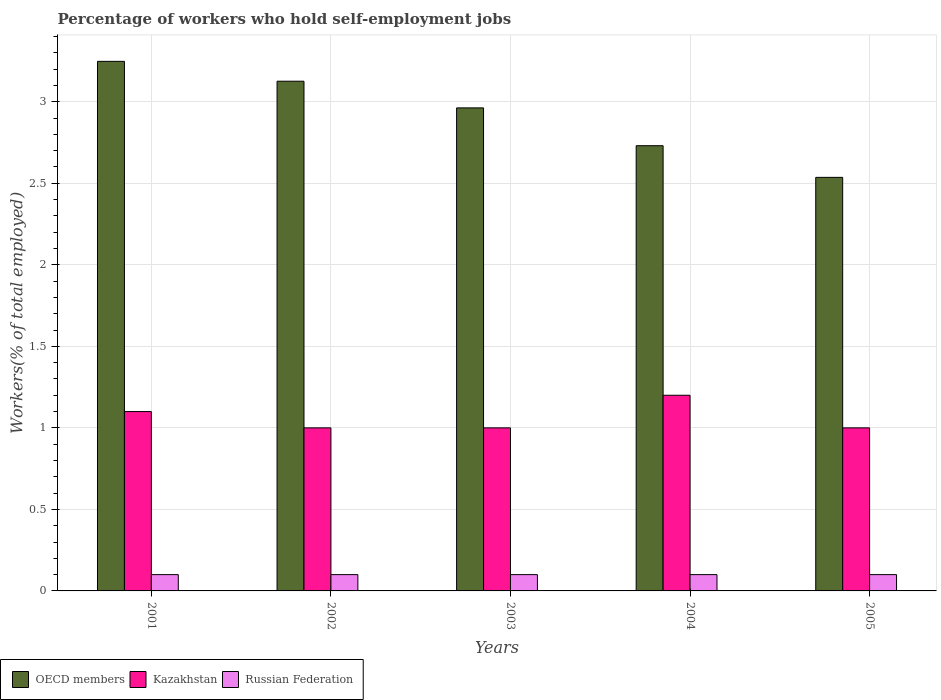How many groups of bars are there?
Your answer should be very brief. 5. What is the percentage of self-employed workers in Russian Federation in 2002?
Your response must be concise. 0.1. Across all years, what is the maximum percentage of self-employed workers in OECD members?
Your answer should be very brief. 3.25. In which year was the percentage of self-employed workers in OECD members minimum?
Your answer should be very brief. 2005. What is the total percentage of self-employed workers in OECD members in the graph?
Ensure brevity in your answer.  14.6. What is the difference between the percentage of self-employed workers in Kazakhstan in 2002 and that in 2003?
Keep it short and to the point. 0. What is the difference between the percentage of self-employed workers in Kazakhstan in 2001 and the percentage of self-employed workers in OECD members in 2002?
Offer a terse response. -2.03. What is the average percentage of self-employed workers in Kazakhstan per year?
Ensure brevity in your answer.  1.06. In the year 2001, what is the difference between the percentage of self-employed workers in Russian Federation and percentage of self-employed workers in Kazakhstan?
Provide a succinct answer. -1. Is the percentage of self-employed workers in Russian Federation in 2001 less than that in 2005?
Give a very brief answer. No. Is the difference between the percentage of self-employed workers in Russian Federation in 2002 and 2003 greater than the difference between the percentage of self-employed workers in Kazakhstan in 2002 and 2003?
Make the answer very short. No. What is the difference between the highest and the lowest percentage of self-employed workers in Russian Federation?
Give a very brief answer. 0. Is the sum of the percentage of self-employed workers in OECD members in 2001 and 2003 greater than the maximum percentage of self-employed workers in Russian Federation across all years?
Give a very brief answer. Yes. What does the 2nd bar from the left in 2003 represents?
Keep it short and to the point. Kazakhstan. How many bars are there?
Make the answer very short. 15. Are all the bars in the graph horizontal?
Make the answer very short. No. Does the graph contain any zero values?
Your response must be concise. No. Where does the legend appear in the graph?
Keep it short and to the point. Bottom left. What is the title of the graph?
Provide a short and direct response. Percentage of workers who hold self-employment jobs. Does "Slovak Republic" appear as one of the legend labels in the graph?
Provide a short and direct response. No. What is the label or title of the X-axis?
Your answer should be compact. Years. What is the label or title of the Y-axis?
Give a very brief answer. Workers(% of total employed). What is the Workers(% of total employed) of OECD members in 2001?
Provide a succinct answer. 3.25. What is the Workers(% of total employed) of Kazakhstan in 2001?
Give a very brief answer. 1.1. What is the Workers(% of total employed) in Russian Federation in 2001?
Provide a succinct answer. 0.1. What is the Workers(% of total employed) in OECD members in 2002?
Give a very brief answer. 3.13. What is the Workers(% of total employed) of Kazakhstan in 2002?
Keep it short and to the point. 1. What is the Workers(% of total employed) in Russian Federation in 2002?
Offer a very short reply. 0.1. What is the Workers(% of total employed) of OECD members in 2003?
Ensure brevity in your answer.  2.96. What is the Workers(% of total employed) in Kazakhstan in 2003?
Provide a succinct answer. 1. What is the Workers(% of total employed) in Russian Federation in 2003?
Offer a terse response. 0.1. What is the Workers(% of total employed) in OECD members in 2004?
Keep it short and to the point. 2.73. What is the Workers(% of total employed) in Kazakhstan in 2004?
Give a very brief answer. 1.2. What is the Workers(% of total employed) of Russian Federation in 2004?
Provide a succinct answer. 0.1. What is the Workers(% of total employed) in OECD members in 2005?
Ensure brevity in your answer.  2.54. What is the Workers(% of total employed) in Kazakhstan in 2005?
Your response must be concise. 1. What is the Workers(% of total employed) of Russian Federation in 2005?
Provide a succinct answer. 0.1. Across all years, what is the maximum Workers(% of total employed) of OECD members?
Ensure brevity in your answer.  3.25. Across all years, what is the maximum Workers(% of total employed) in Kazakhstan?
Offer a terse response. 1.2. Across all years, what is the maximum Workers(% of total employed) in Russian Federation?
Keep it short and to the point. 0.1. Across all years, what is the minimum Workers(% of total employed) of OECD members?
Your response must be concise. 2.54. Across all years, what is the minimum Workers(% of total employed) of Kazakhstan?
Keep it short and to the point. 1. Across all years, what is the minimum Workers(% of total employed) of Russian Federation?
Ensure brevity in your answer.  0.1. What is the total Workers(% of total employed) in OECD members in the graph?
Give a very brief answer. 14.6. What is the total Workers(% of total employed) in Russian Federation in the graph?
Your answer should be very brief. 0.5. What is the difference between the Workers(% of total employed) in OECD members in 2001 and that in 2002?
Keep it short and to the point. 0.12. What is the difference between the Workers(% of total employed) in Kazakhstan in 2001 and that in 2002?
Provide a succinct answer. 0.1. What is the difference between the Workers(% of total employed) in OECD members in 2001 and that in 2003?
Give a very brief answer. 0.29. What is the difference between the Workers(% of total employed) of Kazakhstan in 2001 and that in 2003?
Provide a succinct answer. 0.1. What is the difference between the Workers(% of total employed) of Russian Federation in 2001 and that in 2003?
Keep it short and to the point. 0. What is the difference between the Workers(% of total employed) in OECD members in 2001 and that in 2004?
Offer a very short reply. 0.52. What is the difference between the Workers(% of total employed) in Russian Federation in 2001 and that in 2004?
Your answer should be very brief. 0. What is the difference between the Workers(% of total employed) of OECD members in 2001 and that in 2005?
Your answer should be very brief. 0.71. What is the difference between the Workers(% of total employed) in Kazakhstan in 2001 and that in 2005?
Your answer should be very brief. 0.1. What is the difference between the Workers(% of total employed) in Russian Federation in 2001 and that in 2005?
Make the answer very short. 0. What is the difference between the Workers(% of total employed) of OECD members in 2002 and that in 2003?
Provide a short and direct response. 0.16. What is the difference between the Workers(% of total employed) of Kazakhstan in 2002 and that in 2003?
Ensure brevity in your answer.  0. What is the difference between the Workers(% of total employed) in OECD members in 2002 and that in 2004?
Your response must be concise. 0.4. What is the difference between the Workers(% of total employed) in Kazakhstan in 2002 and that in 2004?
Offer a terse response. -0.2. What is the difference between the Workers(% of total employed) of OECD members in 2002 and that in 2005?
Offer a very short reply. 0.59. What is the difference between the Workers(% of total employed) of Kazakhstan in 2002 and that in 2005?
Your answer should be compact. 0. What is the difference between the Workers(% of total employed) in Russian Federation in 2002 and that in 2005?
Offer a terse response. 0. What is the difference between the Workers(% of total employed) in OECD members in 2003 and that in 2004?
Make the answer very short. 0.23. What is the difference between the Workers(% of total employed) of Kazakhstan in 2003 and that in 2004?
Ensure brevity in your answer.  -0.2. What is the difference between the Workers(% of total employed) in OECD members in 2003 and that in 2005?
Offer a very short reply. 0.43. What is the difference between the Workers(% of total employed) in Russian Federation in 2003 and that in 2005?
Your response must be concise. 0. What is the difference between the Workers(% of total employed) of OECD members in 2004 and that in 2005?
Provide a short and direct response. 0.19. What is the difference between the Workers(% of total employed) of Kazakhstan in 2004 and that in 2005?
Offer a terse response. 0.2. What is the difference between the Workers(% of total employed) of Russian Federation in 2004 and that in 2005?
Your answer should be very brief. 0. What is the difference between the Workers(% of total employed) in OECD members in 2001 and the Workers(% of total employed) in Kazakhstan in 2002?
Ensure brevity in your answer.  2.25. What is the difference between the Workers(% of total employed) of OECD members in 2001 and the Workers(% of total employed) of Russian Federation in 2002?
Your answer should be compact. 3.15. What is the difference between the Workers(% of total employed) of OECD members in 2001 and the Workers(% of total employed) of Kazakhstan in 2003?
Your response must be concise. 2.25. What is the difference between the Workers(% of total employed) of OECD members in 2001 and the Workers(% of total employed) of Russian Federation in 2003?
Give a very brief answer. 3.15. What is the difference between the Workers(% of total employed) of Kazakhstan in 2001 and the Workers(% of total employed) of Russian Federation in 2003?
Ensure brevity in your answer.  1. What is the difference between the Workers(% of total employed) of OECD members in 2001 and the Workers(% of total employed) of Kazakhstan in 2004?
Provide a short and direct response. 2.05. What is the difference between the Workers(% of total employed) of OECD members in 2001 and the Workers(% of total employed) of Russian Federation in 2004?
Offer a very short reply. 3.15. What is the difference between the Workers(% of total employed) of OECD members in 2001 and the Workers(% of total employed) of Kazakhstan in 2005?
Offer a terse response. 2.25. What is the difference between the Workers(% of total employed) in OECD members in 2001 and the Workers(% of total employed) in Russian Federation in 2005?
Give a very brief answer. 3.15. What is the difference between the Workers(% of total employed) in OECD members in 2002 and the Workers(% of total employed) in Kazakhstan in 2003?
Your answer should be very brief. 2.13. What is the difference between the Workers(% of total employed) of OECD members in 2002 and the Workers(% of total employed) of Russian Federation in 2003?
Your answer should be very brief. 3.03. What is the difference between the Workers(% of total employed) in OECD members in 2002 and the Workers(% of total employed) in Kazakhstan in 2004?
Make the answer very short. 1.93. What is the difference between the Workers(% of total employed) in OECD members in 2002 and the Workers(% of total employed) in Russian Federation in 2004?
Offer a terse response. 3.03. What is the difference between the Workers(% of total employed) in OECD members in 2002 and the Workers(% of total employed) in Kazakhstan in 2005?
Give a very brief answer. 2.13. What is the difference between the Workers(% of total employed) in OECD members in 2002 and the Workers(% of total employed) in Russian Federation in 2005?
Keep it short and to the point. 3.03. What is the difference between the Workers(% of total employed) in Kazakhstan in 2002 and the Workers(% of total employed) in Russian Federation in 2005?
Keep it short and to the point. 0.9. What is the difference between the Workers(% of total employed) of OECD members in 2003 and the Workers(% of total employed) of Kazakhstan in 2004?
Offer a very short reply. 1.76. What is the difference between the Workers(% of total employed) in OECD members in 2003 and the Workers(% of total employed) in Russian Federation in 2004?
Keep it short and to the point. 2.86. What is the difference between the Workers(% of total employed) of Kazakhstan in 2003 and the Workers(% of total employed) of Russian Federation in 2004?
Your answer should be very brief. 0.9. What is the difference between the Workers(% of total employed) of OECD members in 2003 and the Workers(% of total employed) of Kazakhstan in 2005?
Give a very brief answer. 1.96. What is the difference between the Workers(% of total employed) in OECD members in 2003 and the Workers(% of total employed) in Russian Federation in 2005?
Offer a very short reply. 2.86. What is the difference between the Workers(% of total employed) of OECD members in 2004 and the Workers(% of total employed) of Kazakhstan in 2005?
Offer a terse response. 1.73. What is the difference between the Workers(% of total employed) of OECD members in 2004 and the Workers(% of total employed) of Russian Federation in 2005?
Provide a short and direct response. 2.63. What is the difference between the Workers(% of total employed) of Kazakhstan in 2004 and the Workers(% of total employed) of Russian Federation in 2005?
Your answer should be very brief. 1.1. What is the average Workers(% of total employed) in OECD members per year?
Offer a very short reply. 2.92. What is the average Workers(% of total employed) in Kazakhstan per year?
Make the answer very short. 1.06. What is the average Workers(% of total employed) of Russian Federation per year?
Offer a terse response. 0.1. In the year 2001, what is the difference between the Workers(% of total employed) of OECD members and Workers(% of total employed) of Kazakhstan?
Keep it short and to the point. 2.15. In the year 2001, what is the difference between the Workers(% of total employed) of OECD members and Workers(% of total employed) of Russian Federation?
Your answer should be very brief. 3.15. In the year 2002, what is the difference between the Workers(% of total employed) in OECD members and Workers(% of total employed) in Kazakhstan?
Offer a very short reply. 2.13. In the year 2002, what is the difference between the Workers(% of total employed) in OECD members and Workers(% of total employed) in Russian Federation?
Make the answer very short. 3.03. In the year 2002, what is the difference between the Workers(% of total employed) of Kazakhstan and Workers(% of total employed) of Russian Federation?
Provide a short and direct response. 0.9. In the year 2003, what is the difference between the Workers(% of total employed) of OECD members and Workers(% of total employed) of Kazakhstan?
Ensure brevity in your answer.  1.96. In the year 2003, what is the difference between the Workers(% of total employed) in OECD members and Workers(% of total employed) in Russian Federation?
Keep it short and to the point. 2.86. In the year 2004, what is the difference between the Workers(% of total employed) of OECD members and Workers(% of total employed) of Kazakhstan?
Keep it short and to the point. 1.53. In the year 2004, what is the difference between the Workers(% of total employed) of OECD members and Workers(% of total employed) of Russian Federation?
Your answer should be very brief. 2.63. In the year 2004, what is the difference between the Workers(% of total employed) of Kazakhstan and Workers(% of total employed) of Russian Federation?
Keep it short and to the point. 1.1. In the year 2005, what is the difference between the Workers(% of total employed) of OECD members and Workers(% of total employed) of Kazakhstan?
Keep it short and to the point. 1.54. In the year 2005, what is the difference between the Workers(% of total employed) of OECD members and Workers(% of total employed) of Russian Federation?
Make the answer very short. 2.44. In the year 2005, what is the difference between the Workers(% of total employed) of Kazakhstan and Workers(% of total employed) of Russian Federation?
Provide a succinct answer. 0.9. What is the ratio of the Workers(% of total employed) of OECD members in 2001 to that in 2002?
Offer a very short reply. 1.04. What is the ratio of the Workers(% of total employed) in Kazakhstan in 2001 to that in 2002?
Your answer should be very brief. 1.1. What is the ratio of the Workers(% of total employed) in Russian Federation in 2001 to that in 2002?
Your response must be concise. 1. What is the ratio of the Workers(% of total employed) in OECD members in 2001 to that in 2003?
Give a very brief answer. 1.1. What is the ratio of the Workers(% of total employed) in OECD members in 2001 to that in 2004?
Give a very brief answer. 1.19. What is the ratio of the Workers(% of total employed) in Kazakhstan in 2001 to that in 2004?
Your answer should be compact. 0.92. What is the ratio of the Workers(% of total employed) in OECD members in 2001 to that in 2005?
Make the answer very short. 1.28. What is the ratio of the Workers(% of total employed) in OECD members in 2002 to that in 2003?
Ensure brevity in your answer.  1.06. What is the ratio of the Workers(% of total employed) of Russian Federation in 2002 to that in 2003?
Your answer should be very brief. 1. What is the ratio of the Workers(% of total employed) in OECD members in 2002 to that in 2004?
Your response must be concise. 1.14. What is the ratio of the Workers(% of total employed) of Russian Federation in 2002 to that in 2004?
Your answer should be very brief. 1. What is the ratio of the Workers(% of total employed) in OECD members in 2002 to that in 2005?
Ensure brevity in your answer.  1.23. What is the ratio of the Workers(% of total employed) of OECD members in 2003 to that in 2004?
Give a very brief answer. 1.08. What is the ratio of the Workers(% of total employed) of OECD members in 2003 to that in 2005?
Give a very brief answer. 1.17. What is the ratio of the Workers(% of total employed) of OECD members in 2004 to that in 2005?
Your answer should be compact. 1.08. What is the difference between the highest and the second highest Workers(% of total employed) in OECD members?
Keep it short and to the point. 0.12. What is the difference between the highest and the second highest Workers(% of total employed) in Russian Federation?
Give a very brief answer. 0. What is the difference between the highest and the lowest Workers(% of total employed) in OECD members?
Keep it short and to the point. 0.71. What is the difference between the highest and the lowest Workers(% of total employed) in Kazakhstan?
Ensure brevity in your answer.  0.2. What is the difference between the highest and the lowest Workers(% of total employed) of Russian Federation?
Provide a succinct answer. 0. 